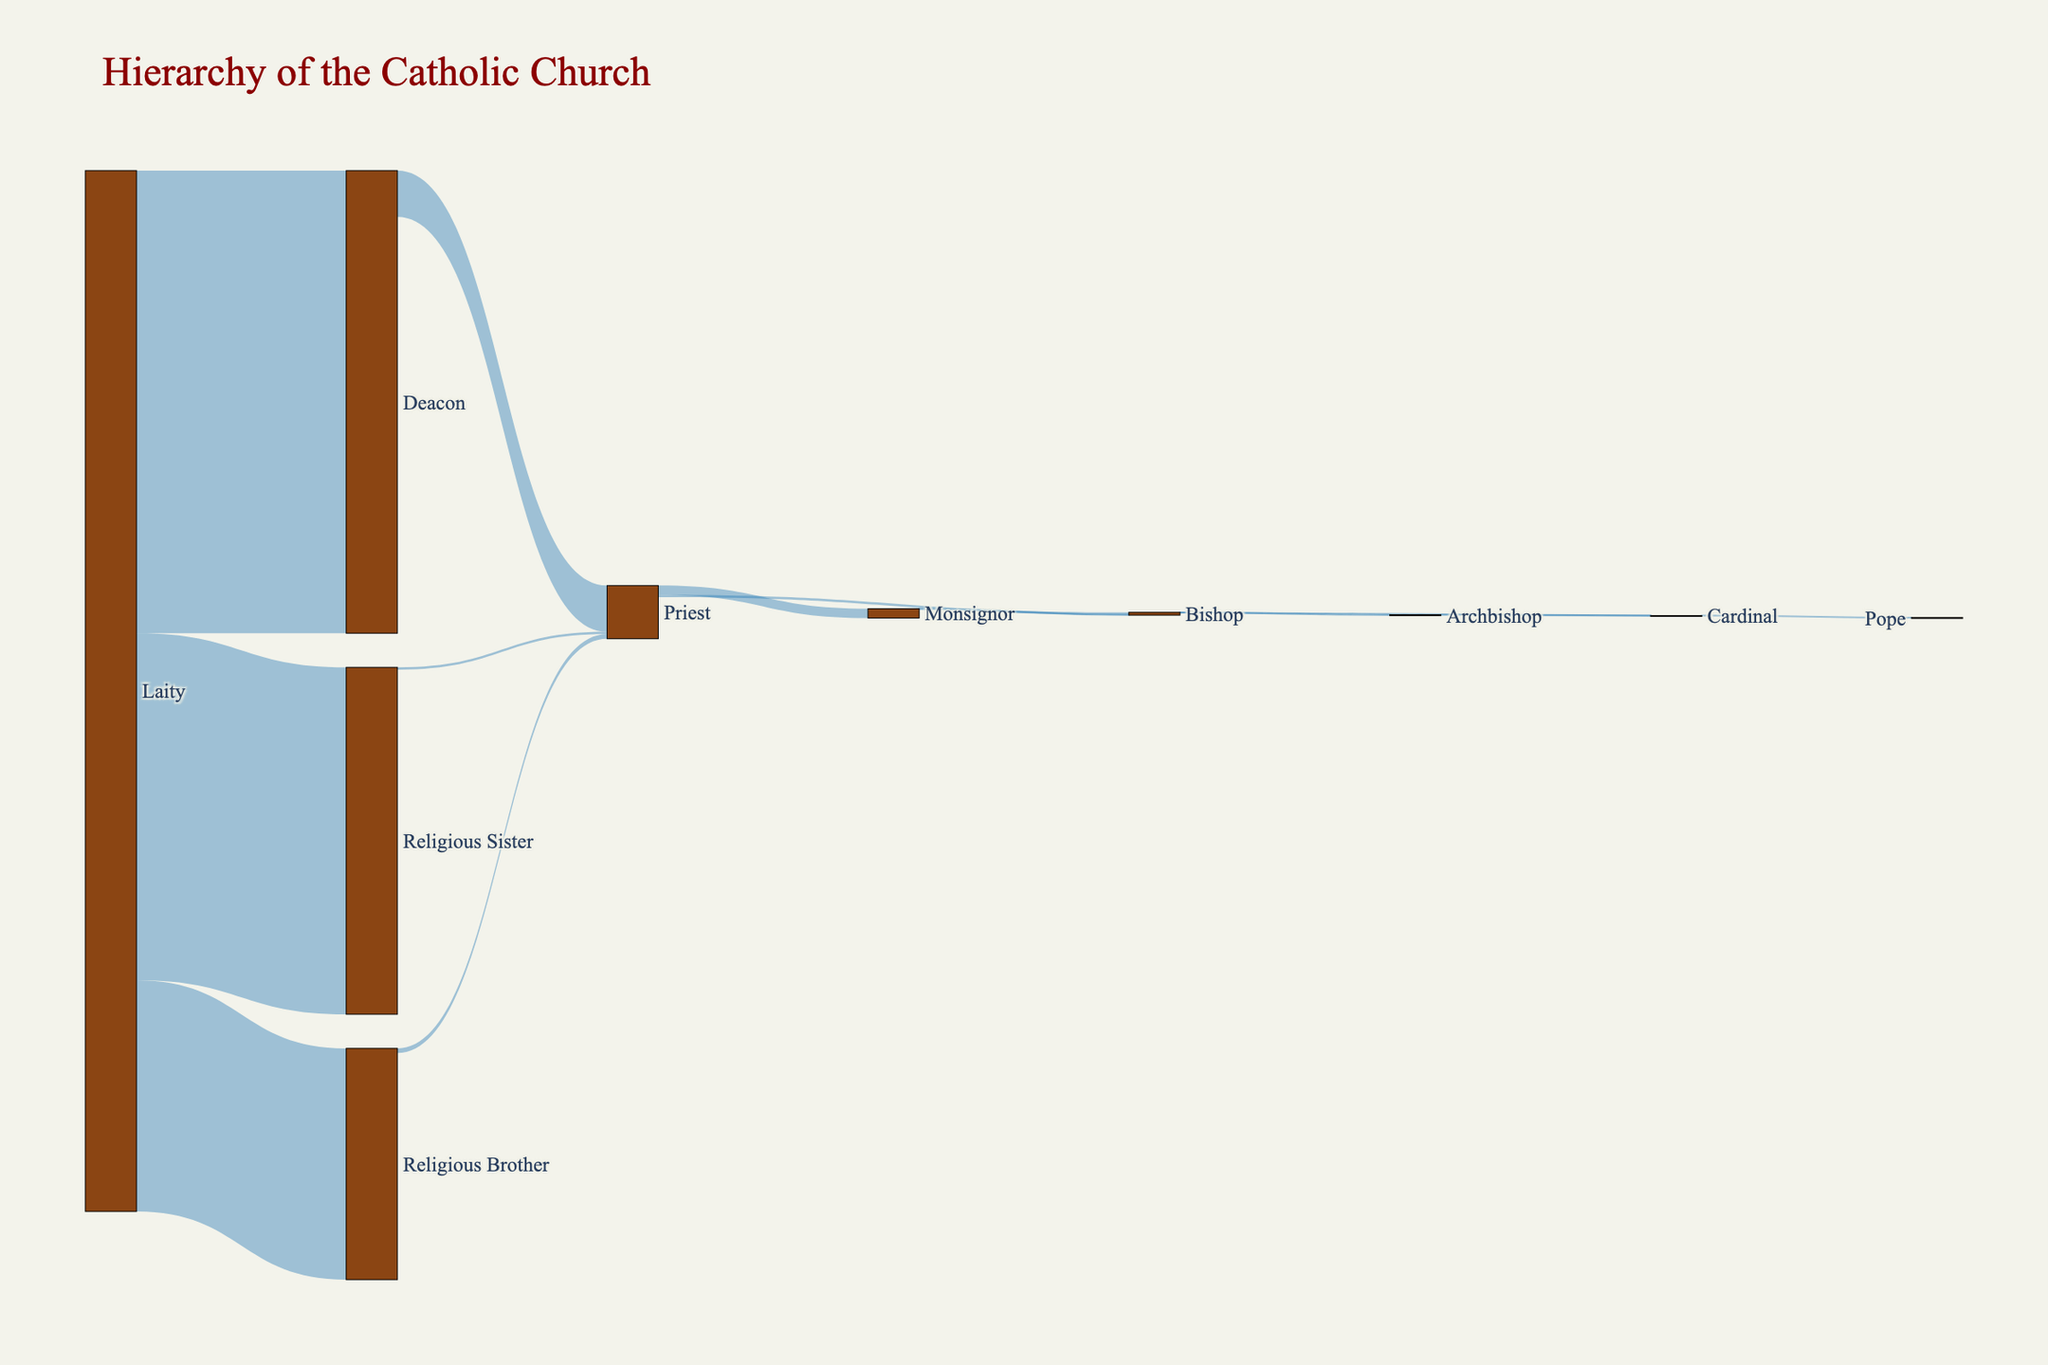How many categories are at the first level of the hierarchy? The first level of the hierarchy consists of 'Laity'. From there, arrows flow into 'Deacon', 'Religious Brother', and 'Religious Sister'. Thus, the first level has one category.
Answer: 1 How many individuals ascend from the 'Laity' to the 'Deacon'? The value linked from 'Laity' to 'Deacon' in the diagram is 1,000,000. This represents the number of individuals moving from the 'Laity' to the 'Deacon'.
Answer: 1,000,000 What is the total number of individuals who ascend to become 'Priest'? To find this, sum the values leading to 'Priest' from 'Deacon', 'Religious Brother', and 'Religious Sister': 100,000 (from 'Deacon') + 10,000 (from 'Religious Brother') + 5,000 (from 'Religious Sister').
Answer: 115,000 Which two categories have a direct connection to ‘Cardinal’? The connections to 'Cardinal' are from 'Bishop' and 'Archbishop'. Hence, these two categories are connected directly to 'Cardinal'.
Answer: Bishop and Archbishop Compare the number of individuals moving from 'Priest' to 'Monsignor' with those moving from 'Priest' to 'Bishop'. Which one is larger, and by how much? The number moving from 'Priest' to 'Monsignor' is 20,000, while from 'Priest' to 'Bishop' is 5,000. Therefore, 20,000 - 5,000 = 15,000 more individuals ascend to 'Monsignor' compared to 'Bishop'.
Answer: Monsignor by 15,000 How many individuals are represented in the ‘Deacon’ category in total? The link from 'Laity' to 'Deacon' has 1,000,000 individuals, but all these do not further ascend; only 100,000 move to the 'Priest'. The remaining in 'Deacon' itself is 1,000,000 - 100,000 = 900,000.
Answer: 900,000 Identify the hierarchy level with the smallest number of individuals. The 'Pope' is the only position at the top of the hierarchy, with a value of 1, representing the smallest number of individuals.
Answer: Pope How many categories in the hierarchy have direct connections to multiple other categories? 'Laity', 'Priest', and 'Bishop' are the categories with multiple connections. 'Laity' connects to 'Deacon', 'Religious Brother', and 'Religious Sister'. 'Priest' connects to both 'Monsignor' and 'Bishop'. 'Bishop' connects to 'Archbishop' and 'Cardinal'.
Answer: 3 